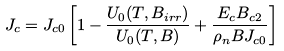Convert formula to latex. <formula><loc_0><loc_0><loc_500><loc_500>J _ { c } = J _ { c 0 } \left [ 1 - \frac { U _ { 0 } ( T , B _ { i r r } ) } { U _ { 0 } ( T , B ) } + \frac { E _ { c } B _ { c 2 } } { \rho _ { n } B J _ { c 0 } } \right ]</formula> 